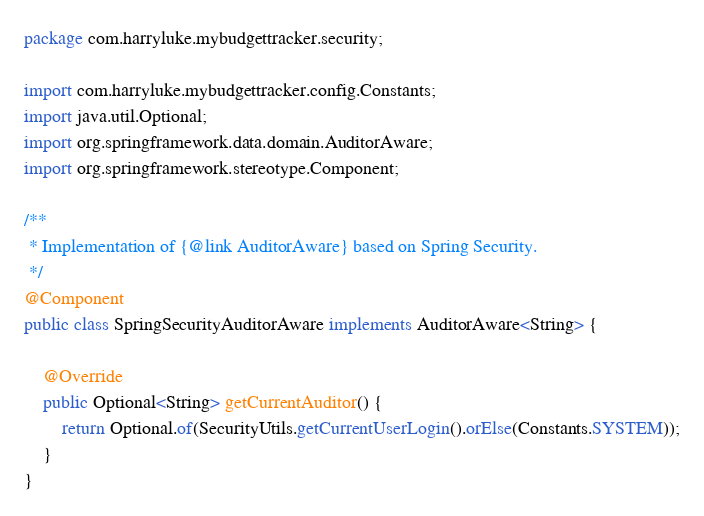Convert code to text. <code><loc_0><loc_0><loc_500><loc_500><_Java_>package com.harryluke.mybudgettracker.security;

import com.harryluke.mybudgettracker.config.Constants;
import java.util.Optional;
import org.springframework.data.domain.AuditorAware;
import org.springframework.stereotype.Component;

/**
 * Implementation of {@link AuditorAware} based on Spring Security.
 */
@Component
public class SpringSecurityAuditorAware implements AuditorAware<String> {

    @Override
    public Optional<String> getCurrentAuditor() {
        return Optional.of(SecurityUtils.getCurrentUserLogin().orElse(Constants.SYSTEM));
    }
}
</code> 